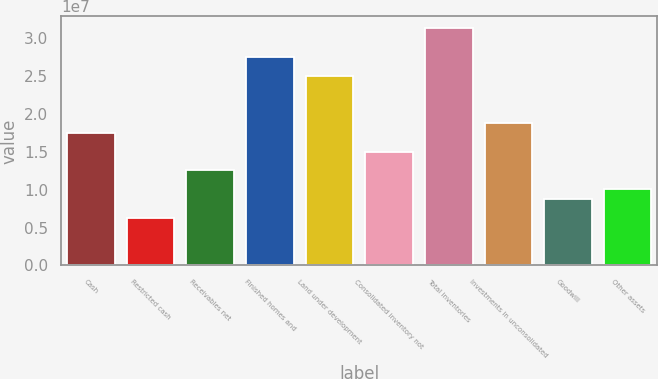Convert chart. <chart><loc_0><loc_0><loc_500><loc_500><bar_chart><fcel>Cash<fcel>Restricted cash<fcel>Receivables net<fcel>Finished homes and<fcel>Land under development<fcel>Consolidated inventory not<fcel>Total inventories<fcel>Investments in unconsolidated<fcel>Goodwill<fcel>Other assets<nl><fcel>1.75564e+07<fcel>6.27225e+06<fcel>1.25412e+07<fcel>2.75868e+07<fcel>2.50792e+07<fcel>1.50488e+07<fcel>3.13481e+07<fcel>1.88102e+07<fcel>8.77984e+06<fcel>1.00336e+07<nl></chart> 